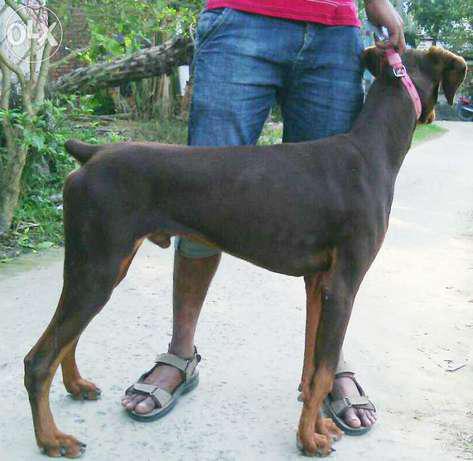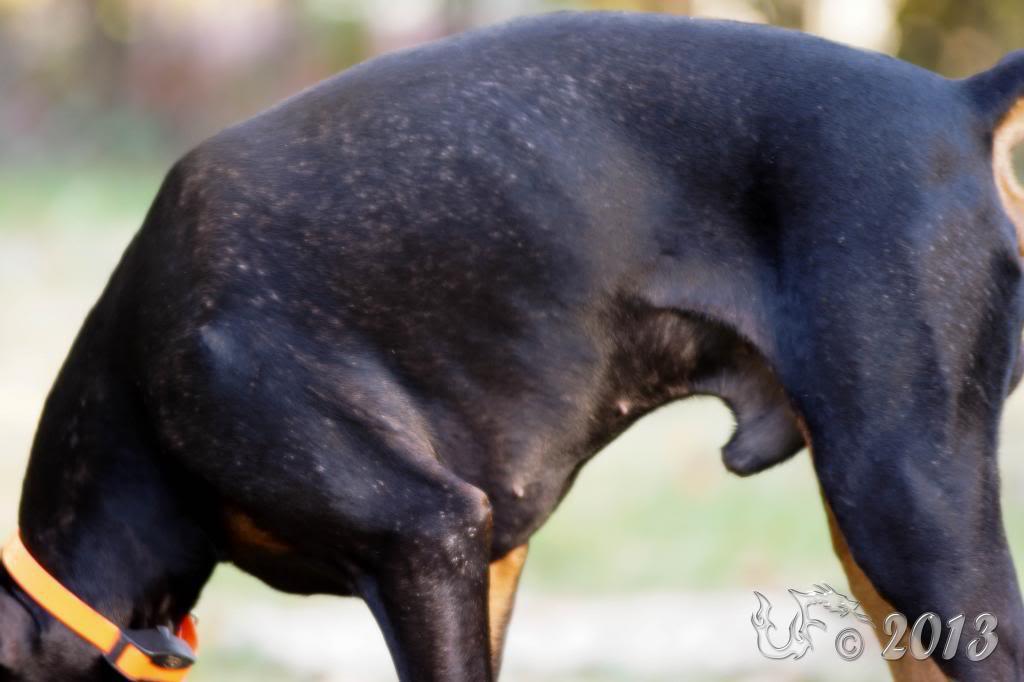The first image is the image on the left, the second image is the image on the right. Examine the images to the left and right. Is the description "A dog's full face is visible." accurate? Answer yes or no. No. The first image is the image on the left, the second image is the image on the right. Given the left and right images, does the statement "Each image shows a dog standing in profile, and the dogs in the left and right images have their bodies turned toward each other." hold true? Answer yes or no. Yes. 